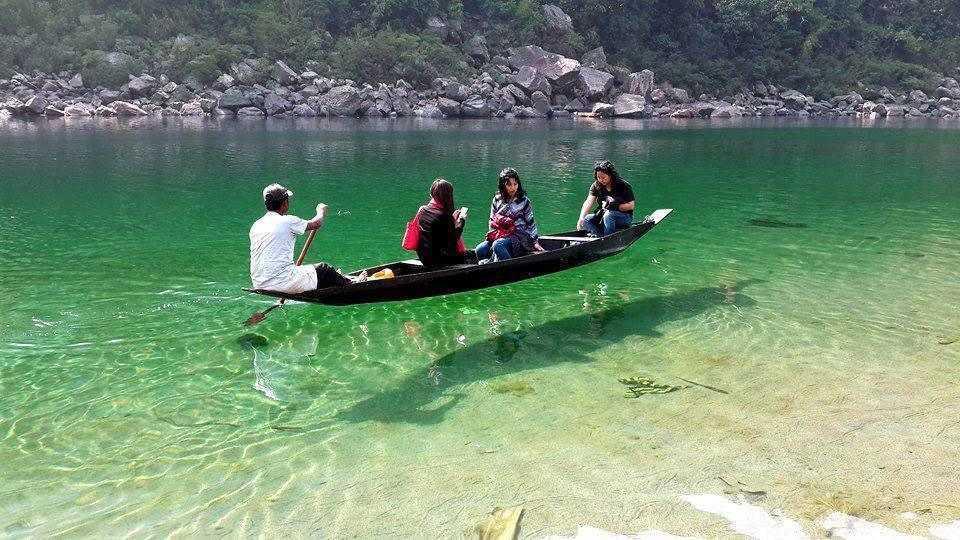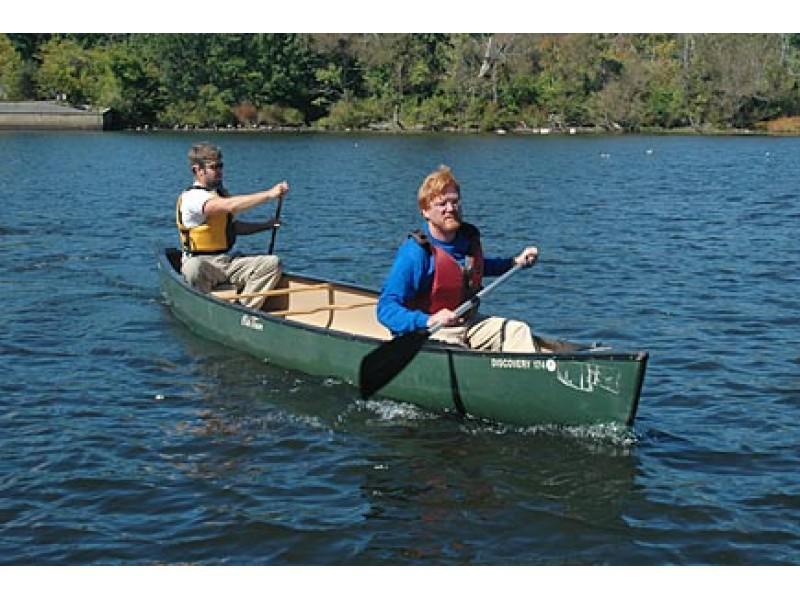The first image is the image on the left, the second image is the image on the right. Given the left and right images, does the statement "There are three or less people in boats" hold true? Answer yes or no. No. The first image is the image on the left, the second image is the image on the right. Evaluate the accuracy of this statement regarding the images: "Atleast one image has more than one boat". Is it true? Answer yes or no. No. 